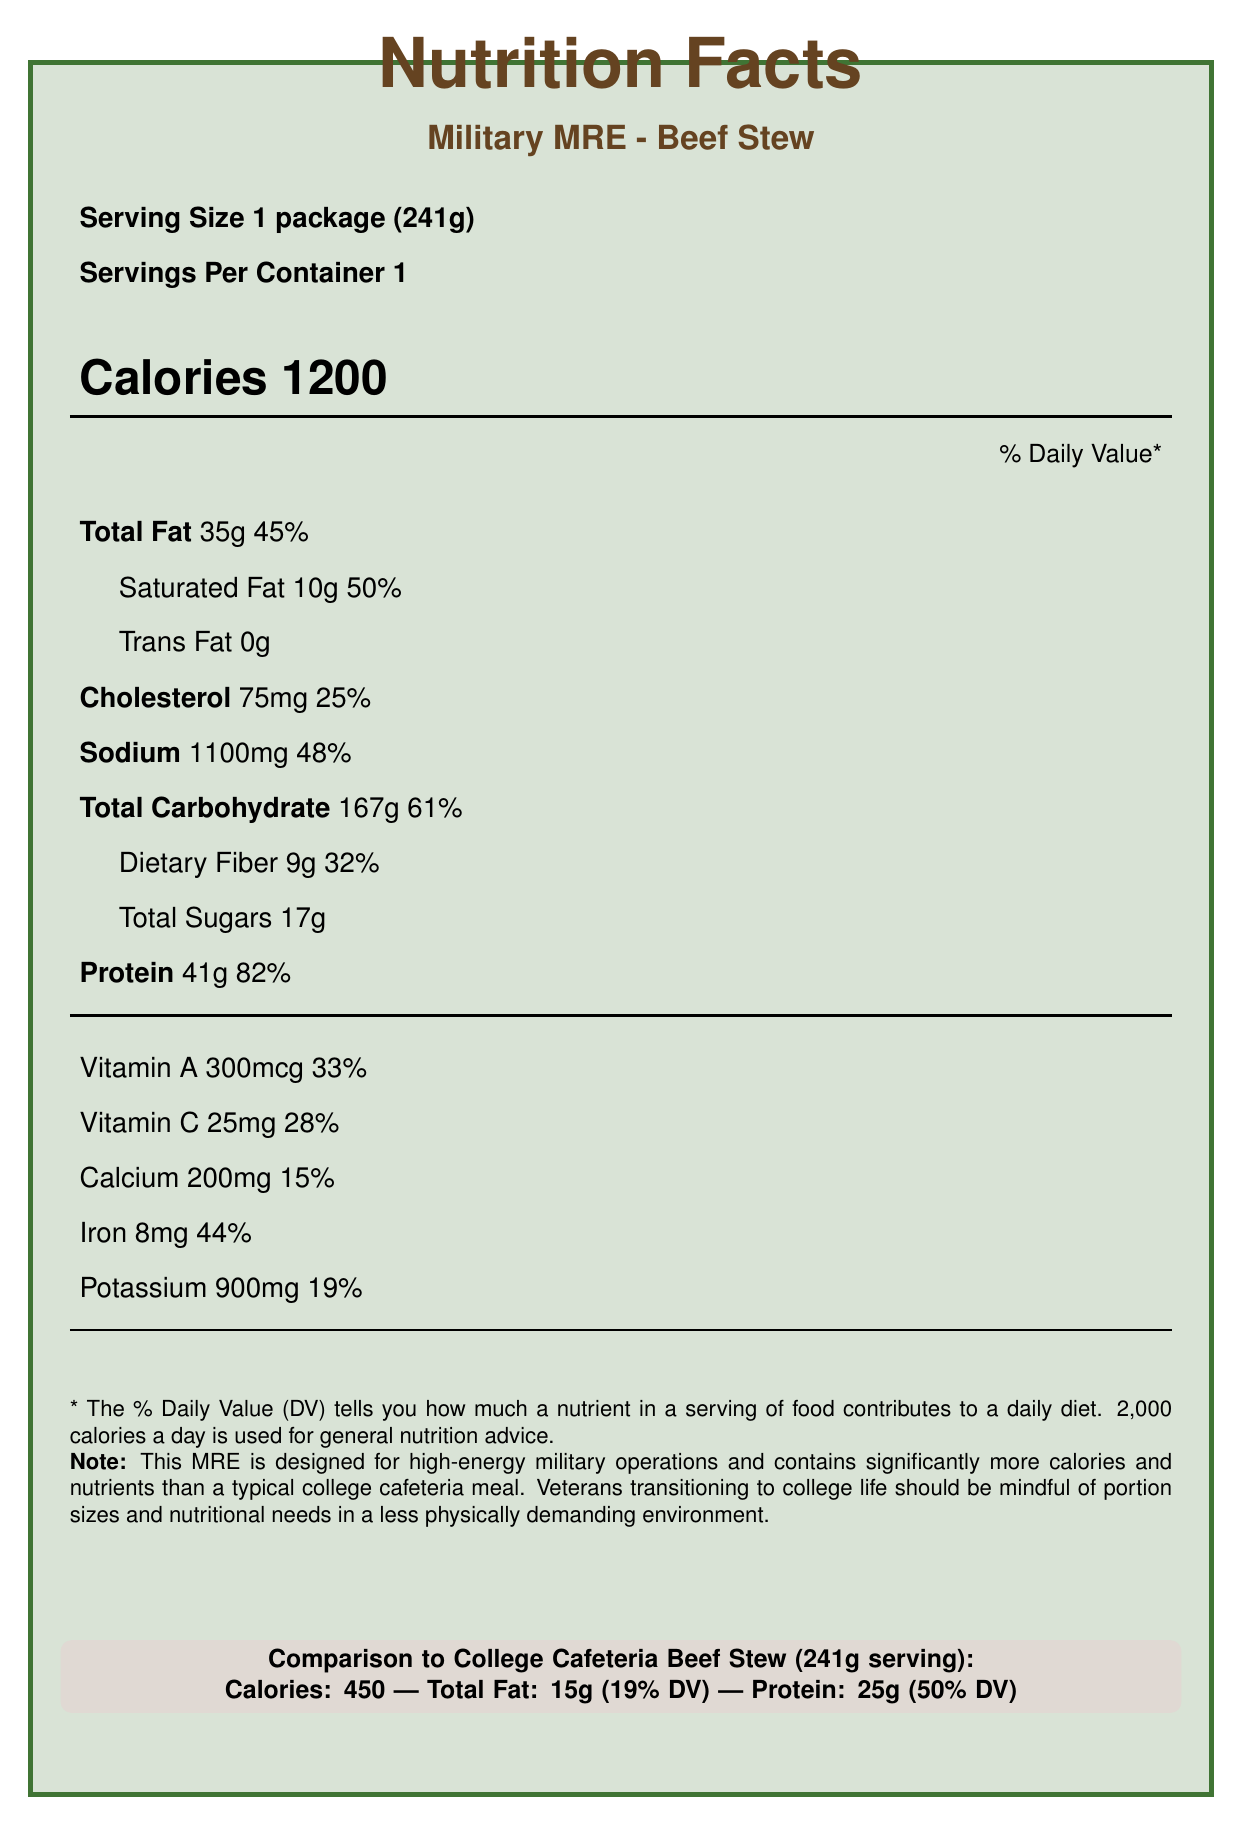What is the serving size of the Military MRE - Beef Stew? The serving size is listed at the beginning of the Nutrition Facts section.
Answer: 1 package (241g) How many calories are in a serving of the Military MRE - Beef Stew? The calories are prominently displayed as 1200 in the Calorie information section.
Answer: 1200 What is the total amount of fat in the Military MRE - Beef Stew, and what percentage of the daily value does it represent? The document lists Total Fat as 35g and indicates this represents 45% of the daily value.
Answer: 35g, 45% How much protein is in one serving of the Military MRE - Beef Stew? Under the nutrient information, Protein is listed with an amount of 41g.
Answer: 41g What is the sodium content of the Military MRE - Beef Stew, and how does it compare to the College Cafeteria Beef Stew? The sodium content for the Military MRE is 1100mg, while the College Cafeteria Beef Stew has 800mg.
Answer: MRE: 1100mg, Cafeteria: 800mg Which nutrient has the highest daily value percentage in the Military MRE - Beef Stew? A. Total Fat B. Saturated Fat C. Protein D. Sodium The daily value percentages listed show Protein at 82%, the highest among the options.
Answer: C. Protein Which meal has more calories per serving? A. Military MRE - Beef Stew B. College Cafeteria - Beef Stew The Military MRE - Beef Stew has 1200 calories per serving compared to the College Cafeteria Beef Stew's 450 calories.
Answer: A. Military MRE - Beef Stew Is the Military MRE - Beef Stew designed to be high in energy? The document mentions the MRE is high in energy, evident from its high calorie count and purpose for military operations.
Answer: Yes Summarize the key nutritional differences between Military MRE - Beef Stew and College Cafeteria Beef Stew. The MRE is meant for high-energy military operations, whereas cafeteria food is targeted for less physically demanding college life. The MRE is fortified with vitamins and minerals and has a higher sodium content to replace electrolytes lost during strenuous activities.
Answer: The Military MRE - Beef Stew has significantly higher calories, fat, carbohydrates, and protein compared to the College Cafeteria Beef Stew. It is designed for high-energy needs in the military, with fortified nutrients and higher sodium content to support physical activities. In contrast, the cafeteria stew is lower in calories and nutrients. What is the long-term storage capability of MREs compared to fresh cafeteria food? This information is mentioned in the veteran perspective section, highlighting the difference in shelf life.
Answer: MREs have a shelf life of up to 5 years. How much dietary fiber is in the Military MRE - Beef Stew? The dietary fiber is listed under the Total Carbohydrate section with an amount of 9g.
Answer: 9g What is the percent daily value of cholesterol in the Military MRE - Beef Stew? The percent daily value for cholesterol is listed as 25%.
Answer: 25% Which meal is likely to be more suitable for someone involved in intense physical activity? The Military MRE is designed for high-energy output situations like military field operations, with higher calories and nutrient density.
Answer: Military MRE - Beef Stew What is the total carbohydrate content in the College Cafeteria Beef Stew? The total carbohydrate content for the College Cafeteria Beef Stew is listed as 60g.
Answer: 60g Can we determine the exact ingredients used in the Military MRE - Beef Stew from the document? The document provides nutritional facts but does not disclose the exact ingredient list used in the MRE.
Answer: Not enough information 